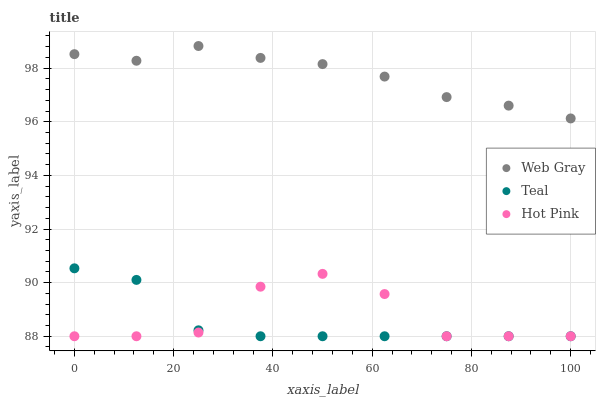Does Teal have the minimum area under the curve?
Answer yes or no. Yes. Does Web Gray have the maximum area under the curve?
Answer yes or no. Yes. Does Hot Pink have the minimum area under the curve?
Answer yes or no. No. Does Hot Pink have the maximum area under the curve?
Answer yes or no. No. Is Web Gray the smoothest?
Answer yes or no. Yes. Is Hot Pink the roughest?
Answer yes or no. Yes. Is Teal the smoothest?
Answer yes or no. No. Is Teal the roughest?
Answer yes or no. No. Does Teal have the lowest value?
Answer yes or no. Yes. Does Web Gray have the highest value?
Answer yes or no. Yes. Does Teal have the highest value?
Answer yes or no. No. Is Hot Pink less than Web Gray?
Answer yes or no. Yes. Is Web Gray greater than Hot Pink?
Answer yes or no. Yes. Does Teal intersect Hot Pink?
Answer yes or no. Yes. Is Teal less than Hot Pink?
Answer yes or no. No. Is Teal greater than Hot Pink?
Answer yes or no. No. Does Hot Pink intersect Web Gray?
Answer yes or no. No. 